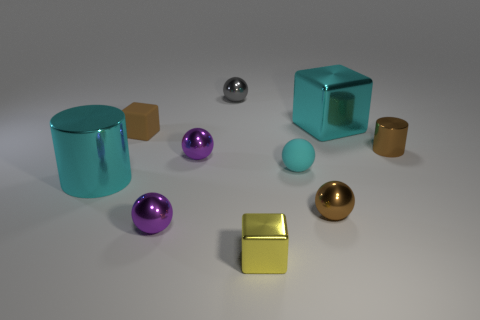Does the metal cylinder that is on the right side of the tiny matte cube have the same color as the small matte block?
Your answer should be very brief. Yes. Is the large cyan cylinder made of the same material as the gray thing?
Give a very brief answer. Yes. Are there the same number of yellow blocks left of the tiny brown block and tiny brown metal objects behind the tiny brown sphere?
Keep it short and to the point. No. There is a large cyan object that is the same shape as the small yellow shiny object; what material is it?
Your response must be concise. Metal. There is a brown object in front of the small matte ball that is to the right of the large cyan object that is in front of the tiny cyan thing; what is its shape?
Your response must be concise. Sphere. Is the number of cyan balls that are right of the big block greater than the number of big cyan metallic things?
Your answer should be compact. No. Do the small rubber thing that is on the right side of the yellow shiny cube and the tiny gray thing have the same shape?
Offer a very short reply. Yes. What is the material of the large cyan thing that is to the left of the rubber ball?
Your response must be concise. Metal. How many gray metal things have the same shape as the cyan matte thing?
Provide a short and direct response. 1. What is the material of the cube that is behind the tiny rubber thing that is on the left side of the gray shiny ball?
Offer a terse response. Metal. 